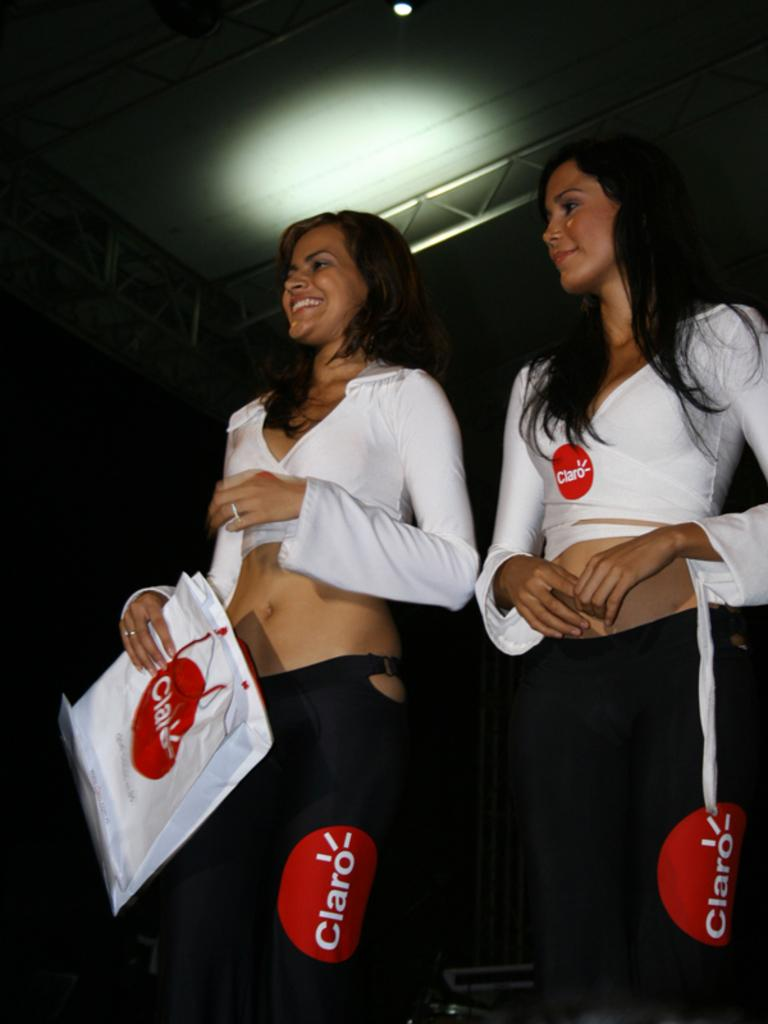<image>
Give a short and clear explanation of the subsequent image. Two girls are wearing matching clothes that say Claro. 